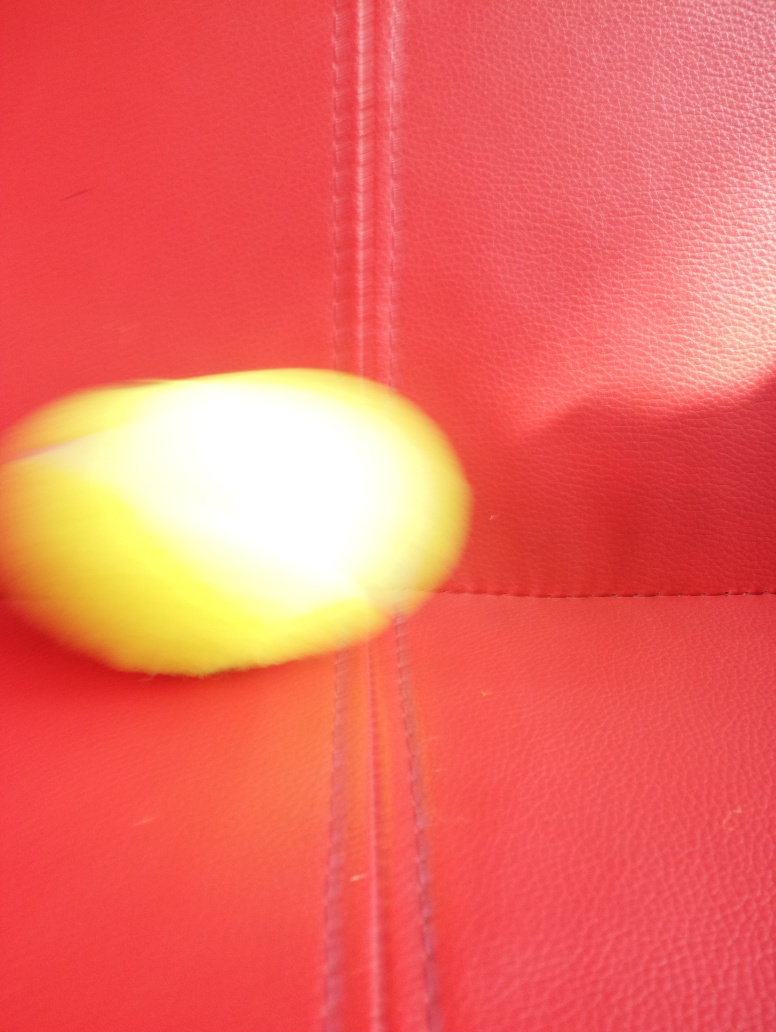Can you describe the color contrast in the image? The image presents a strong color contrast with a vivid yellow object against a deep red background. However, due to the blur, it is challenging to appreciate the full intensity of the colors or the details they may contain. 